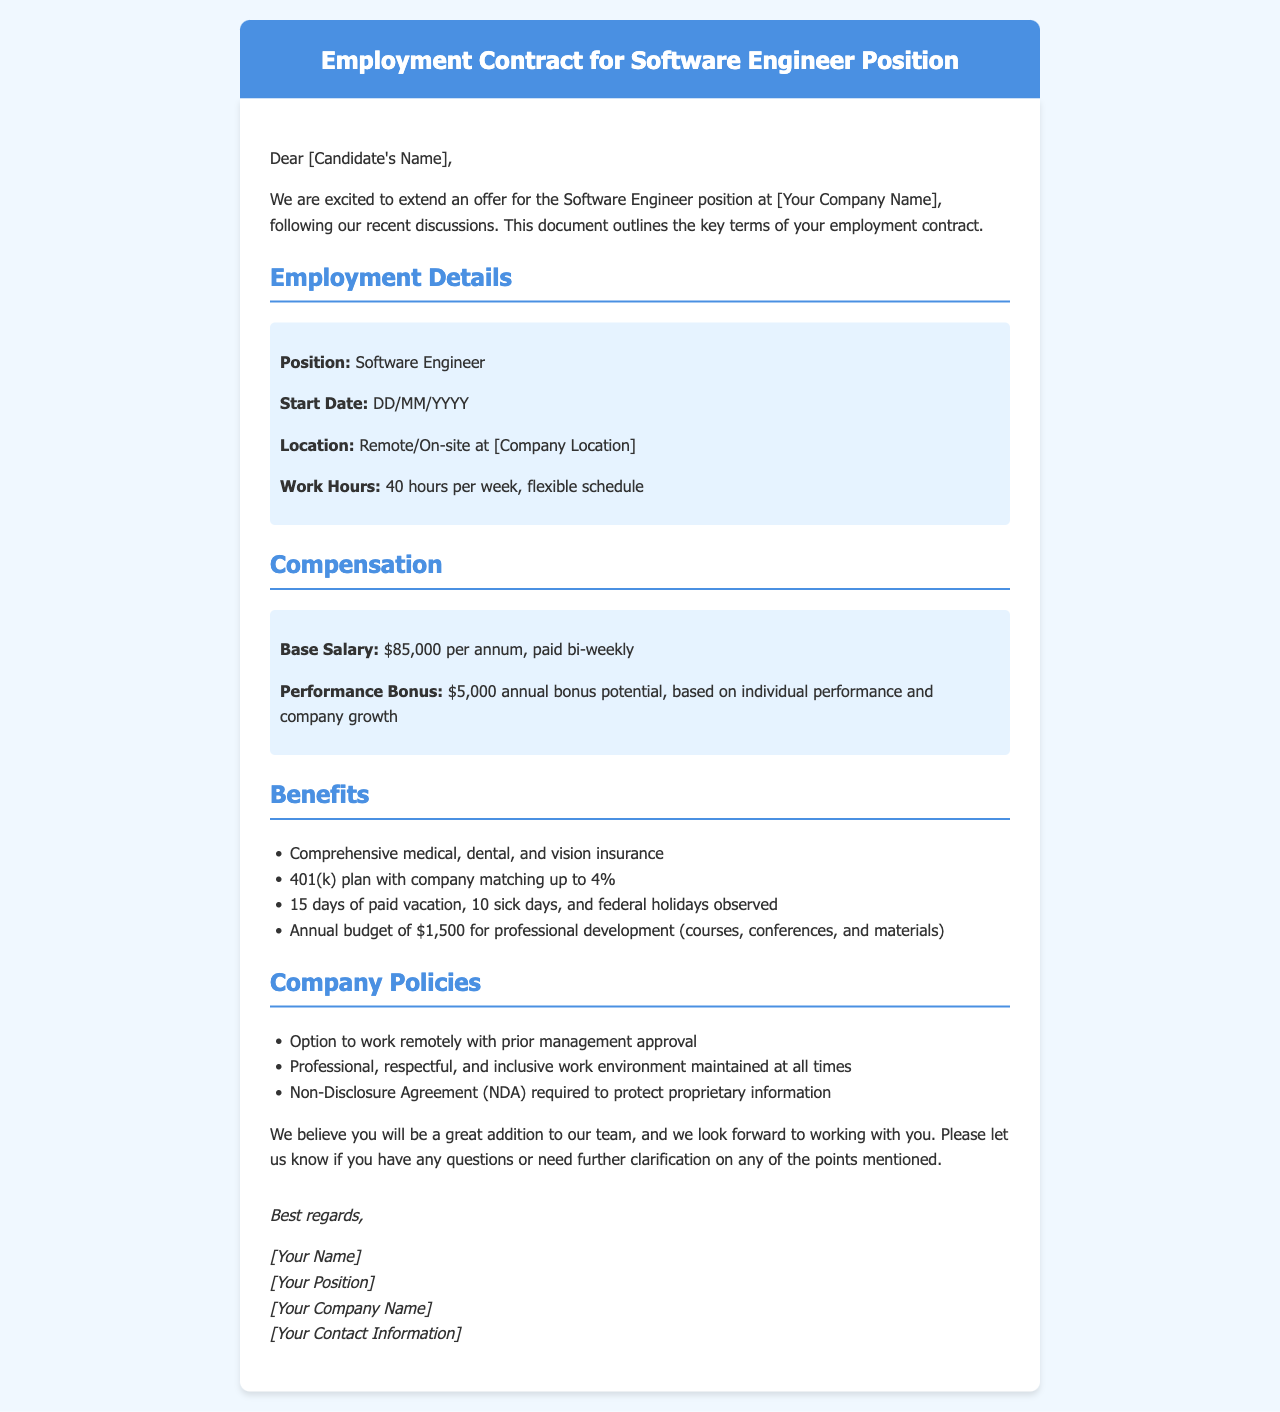What is the base salary? The base salary is specified as part of the compensation section detailing the payment structure.
Answer: $85,000 per annum What is the performance bonus potential? The performance bonus potential is outlined following the base salary in the compensation details.
Answer: $5,000 annual bonus potential How many paid vacation days are offered? The number of paid vacation days is listed under the benefits section of the document.
Answer: 15 days What is the total number of sick days? The total number of sick days is explicitly stated in the benefits section of the contract.
Answer: 10 sick days Is remote work an option? The document mentions company policies regarding work arrangements, including the possibility of remote work.
Answer: Yes What is the company's matching percentage for the 401(k) plan? This detail can be found in the benefits section discussing retirement plans.
Answer: Up to 4% When should the candidate start? The start date is indicated as part of the employment details section.
Answer: DD/MM/YYYY What type of work environment does the company maintain? The work environment is described under company policies, which defines the standards expected.
Answer: Professional, respectful, and inclusive Who should the candidate contact for questions? The closing section of the document provides details on who to reach out to for further inquiries.
Answer: [Your Name] 